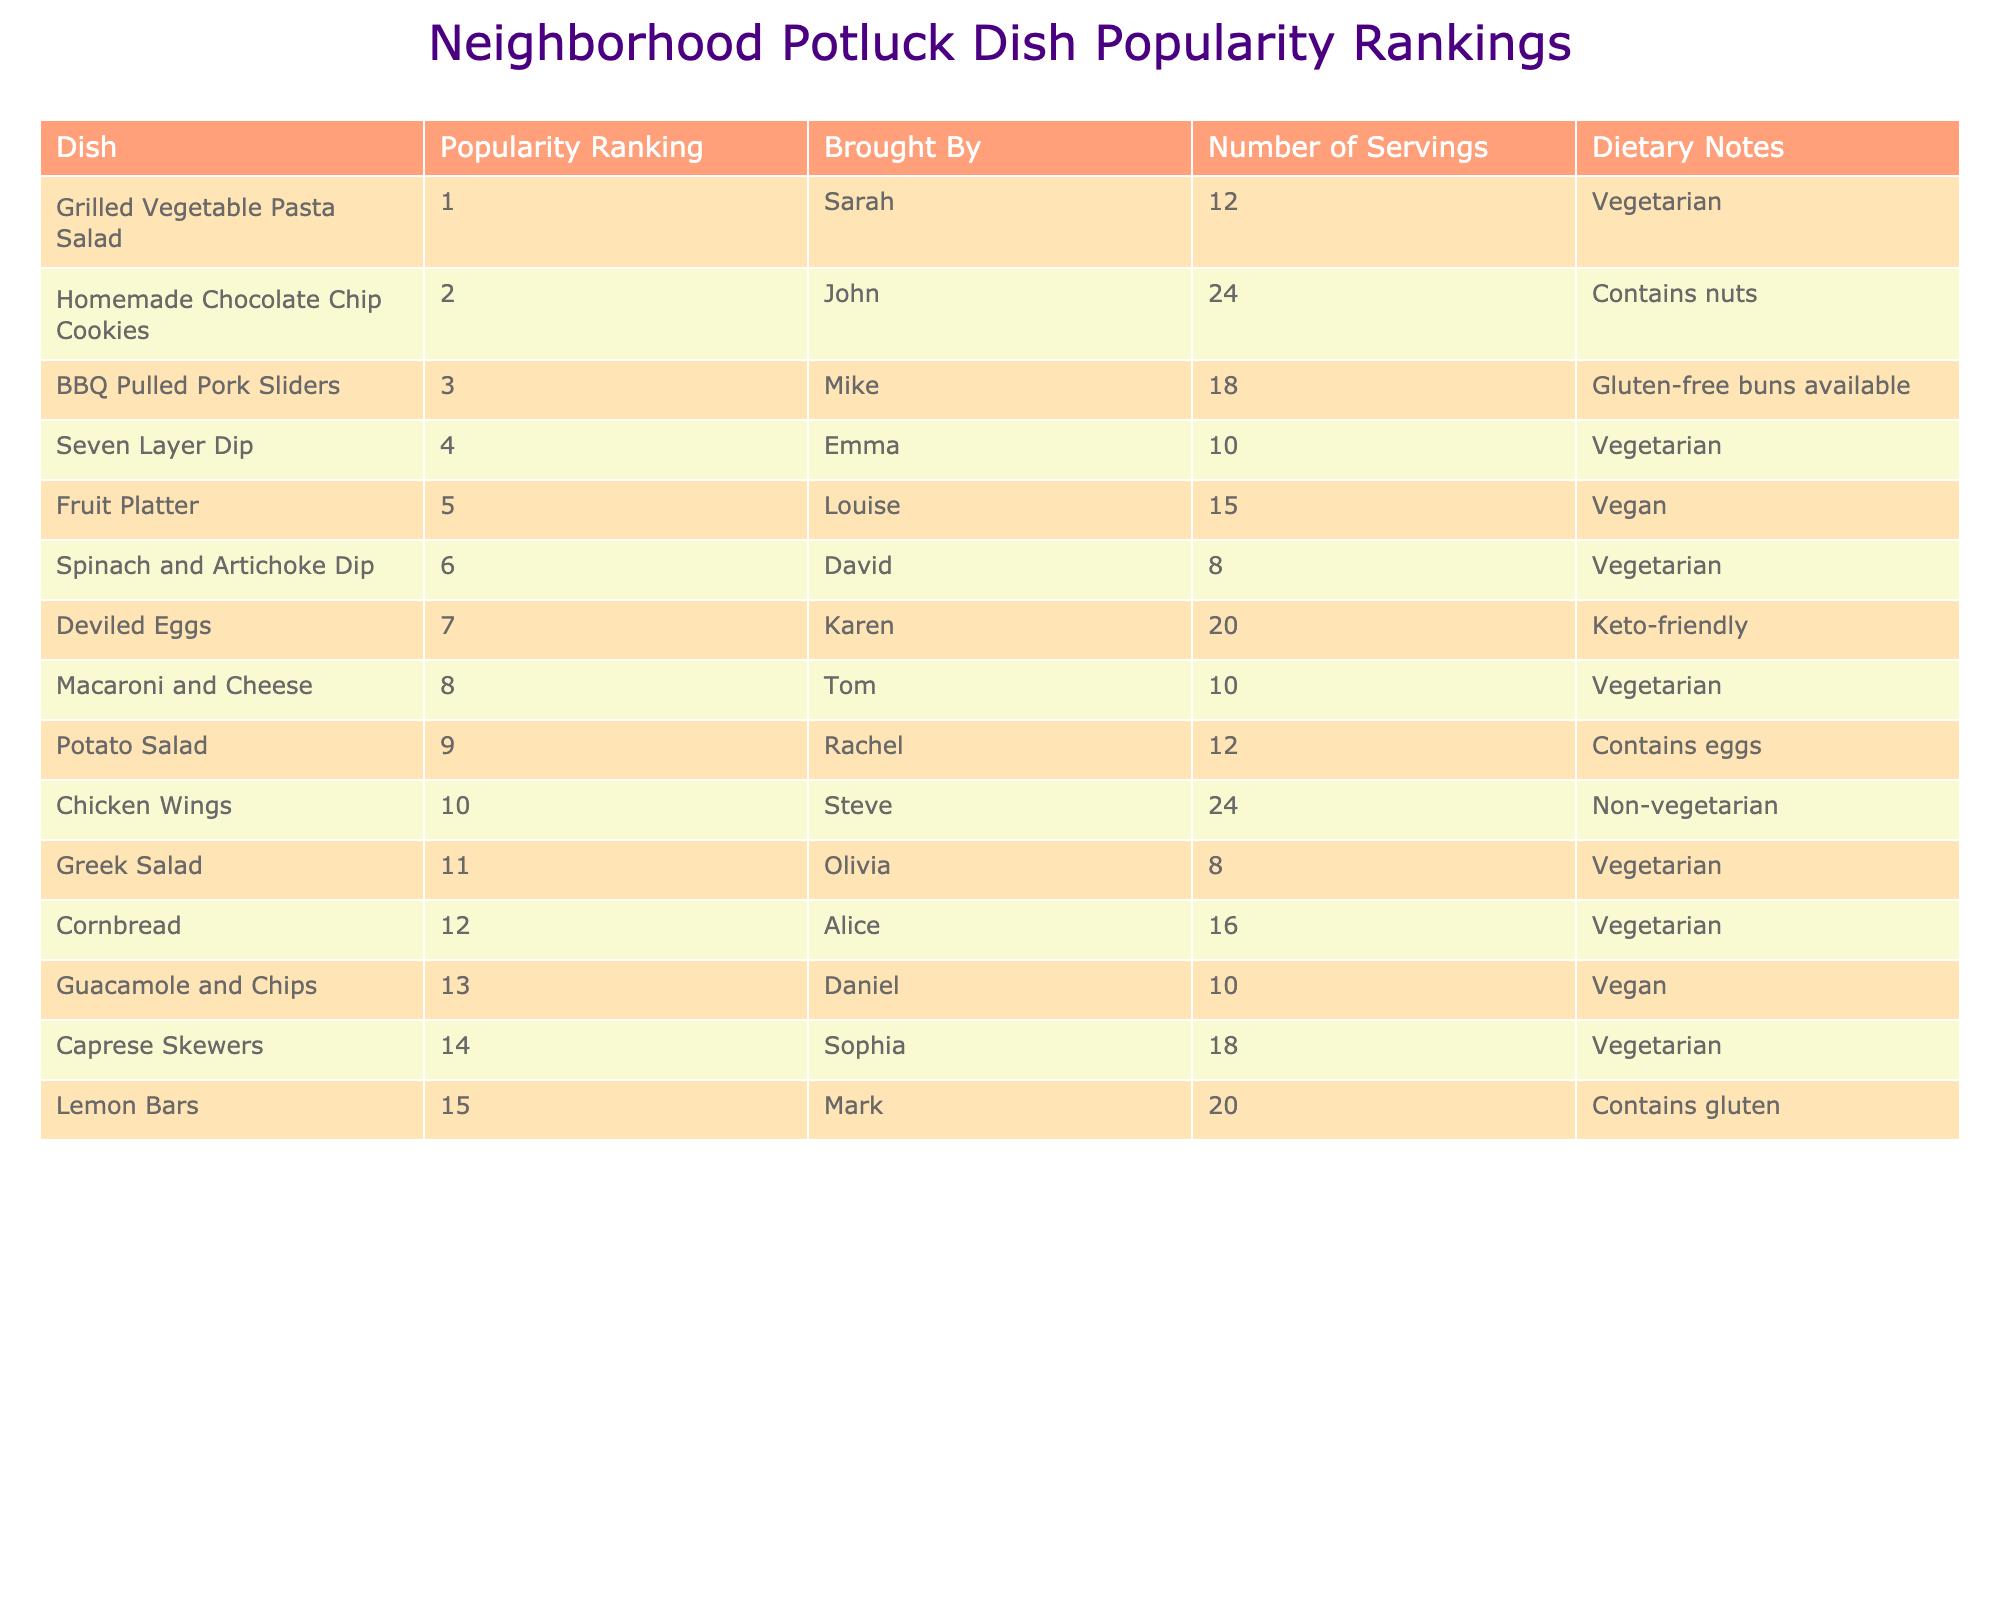What dish is ranked as the most popular? The table shows the "Popularity Ranking" column, and the dish ranked number one is "Grilled Vegetable Pasta Salad".
Answer: Grilled Vegetable Pasta Salad How many servings did John bring? Looking at the "Brought By" column for John, I see that he brought 24 servings.
Answer: 24 Is the Fruit Platter a vegan dish? The "Dietary Notes" for the Fruit Platter states it is Vegan, so the answer is yes.
Answer: Yes Which dish has the least number of servings? By comparing the "Number of Servings" for each dish, the Spinach and Artichoke Dip has 8 servings, which is the least.
Answer: Spinach and Artichoke Dip What is the total number of servings for all vegetarian dishes? By adding the servings for vegetarian dishes: 12 (Grilled Vegetable Pasta Salad) + 10 (Seven Layer Dip) + 15 (Fruit Platter) + 8 (Spinach and Artichoke Dip) + 10 (Macaroni and Cheese) + 8 (Greek Salad) + 16 (Cornbread) + 18 (Caprese Skewers) = 97.
Answer: 97 Did any dish contain gluten? Looking at the "Dietary Notes" section, the Lemon Bars state it contains gluten, so the answer is yes.
Answer: Yes What is the average number of servings for the dishes brought by females? The dishes brought by females (Sarah, Emma, Louise, Karen, Olivia, and Alice) have servings: 12, 10, 15, 20, 8, and 16. Adding these gives 81. There are 6 dishes, so the average is 81/6 = 13.5.
Answer: 13.5 Which dish has a vegetarian note and is ranked higher than 10? The table shows that the Greek Salad is ranked 11 and has a vegetarian note.
Answer: Greek Salad How many dishes were brought by Mike and David combined? Mike brought 18 servings and David brought 8 servings, so combined they brought 18 + 8 = 26 servings.
Answer: 26 Which dish with the highest servings is non-vegetarian? Looking at the table, Chicken Wings is the only dish that is non-vegetarian and has 24 servings, which is the highest.
Answer: Chicken Wings 